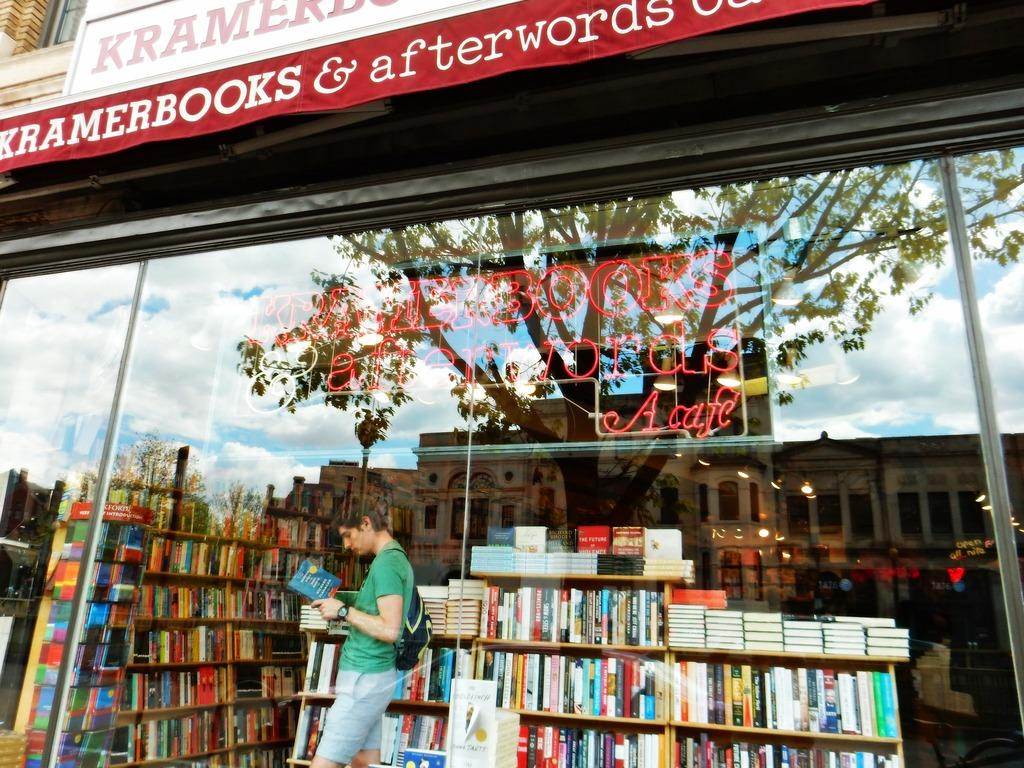Provide a one-sentence caption for the provided image. A man in a green shirt reads a book standing next to a bookshelf at Kramerbooks & afterwords. 